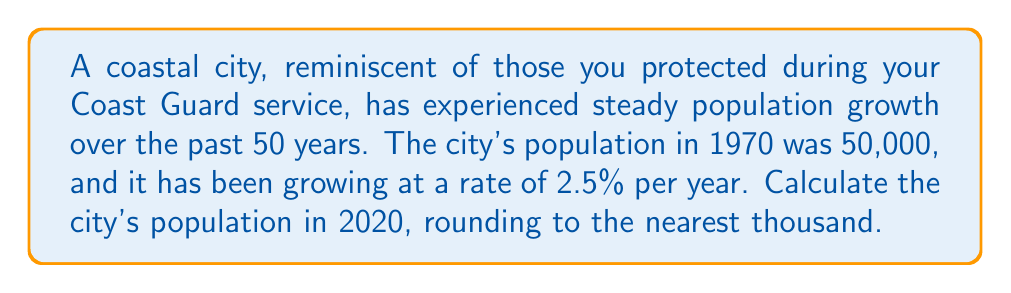Give your solution to this math problem. To solve this problem, we'll use the compound interest formula, as population growth follows a similar pattern:

$$A = P(1 + r)^t$$

Where:
$A$ = Final amount (population in 2020)
$P$ = Initial amount (population in 1970)
$r$ = Annual growth rate
$t$ = Number of years

Given:
$P = 50,000$
$r = 2.5\% = 0.025$
$t = 50$ years (1970 to 2020)

Let's substitute these values into the formula:

$$A = 50,000(1 + 0.025)^{50}$$

Using a calculator or computer:

$$A = 50,000 \times 3.437075$$
$$A = 171,853.75$$

Rounding to the nearest thousand:

$$A \approx 172,000$$
Answer: 172,000 